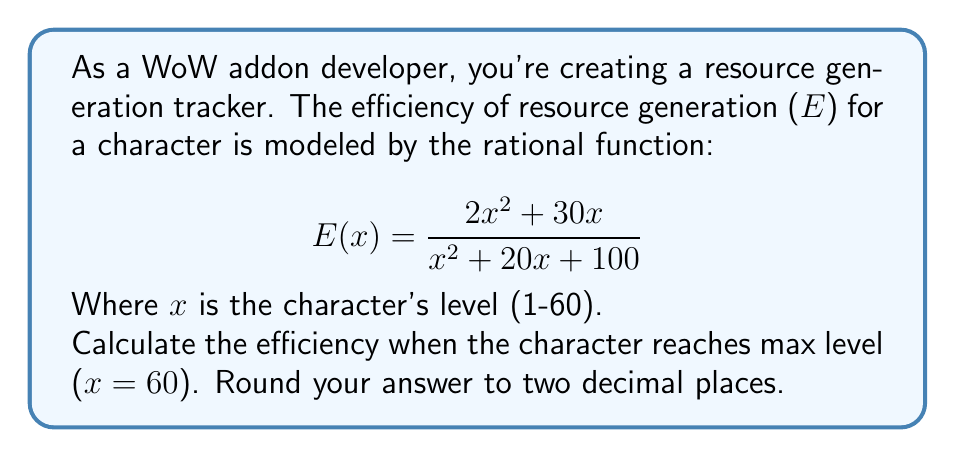Help me with this question. To solve this problem, we'll follow these steps:

1) We're given the rational function for efficiency:
   $$E(x) = \frac{2x^2 + 30x}{x^2 + 20x + 100}$$

2) We need to calculate E(60) as the max level is 60:
   $$E(60) = \frac{2(60)^2 + 30(60)}{(60)^2 + 20(60) + 100}$$

3) Let's simplify the numerator:
   $2(60)^2 = 2(3600) = 7200$
   $30(60) = 1800$
   $7200 + 1800 = 9000$

4) Now the denominator:
   $(60)^2 = 3600$
   $20(60) = 1200$
   $3600 + 1200 + 100 = 4900$

5) Our fraction is now:
   $$E(60) = \frac{9000}{4900}$$

6) Dividing and rounding to two decimal places:
   $9000 \div 4900 \approx 1.8367...$
   Rounded to two decimal places: 1.84

Therefore, the efficiency at max level (60) is approximately 1.84.
Answer: 1.84 